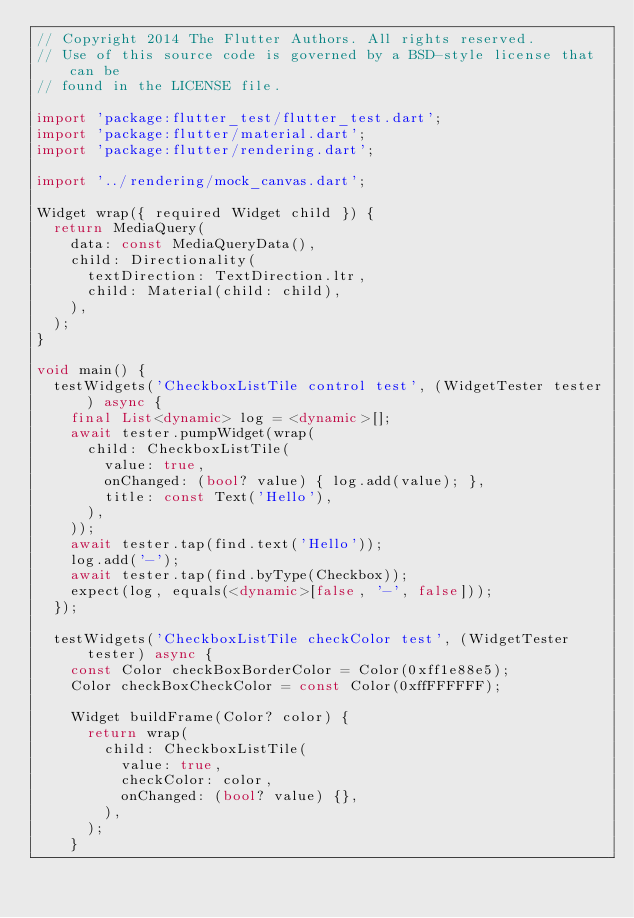<code> <loc_0><loc_0><loc_500><loc_500><_Dart_>// Copyright 2014 The Flutter Authors. All rights reserved.
// Use of this source code is governed by a BSD-style license that can be
// found in the LICENSE file.

import 'package:flutter_test/flutter_test.dart';
import 'package:flutter/material.dart';
import 'package:flutter/rendering.dart';

import '../rendering/mock_canvas.dart';

Widget wrap({ required Widget child }) {
  return MediaQuery(
    data: const MediaQueryData(),
    child: Directionality(
      textDirection: TextDirection.ltr,
      child: Material(child: child),
    ),
  );
}

void main() {
  testWidgets('CheckboxListTile control test', (WidgetTester tester) async {
    final List<dynamic> log = <dynamic>[];
    await tester.pumpWidget(wrap(
      child: CheckboxListTile(
        value: true,
        onChanged: (bool? value) { log.add(value); },
        title: const Text('Hello'),
      ),
    ));
    await tester.tap(find.text('Hello'));
    log.add('-');
    await tester.tap(find.byType(Checkbox));
    expect(log, equals(<dynamic>[false, '-', false]));
  });

  testWidgets('CheckboxListTile checkColor test', (WidgetTester tester) async {
    const Color checkBoxBorderColor = Color(0xff1e88e5);
    Color checkBoxCheckColor = const Color(0xffFFFFFF);

    Widget buildFrame(Color? color) {
      return wrap(
        child: CheckboxListTile(
          value: true,
          checkColor: color,
          onChanged: (bool? value) {},
        ),
      );
    }
</code> 